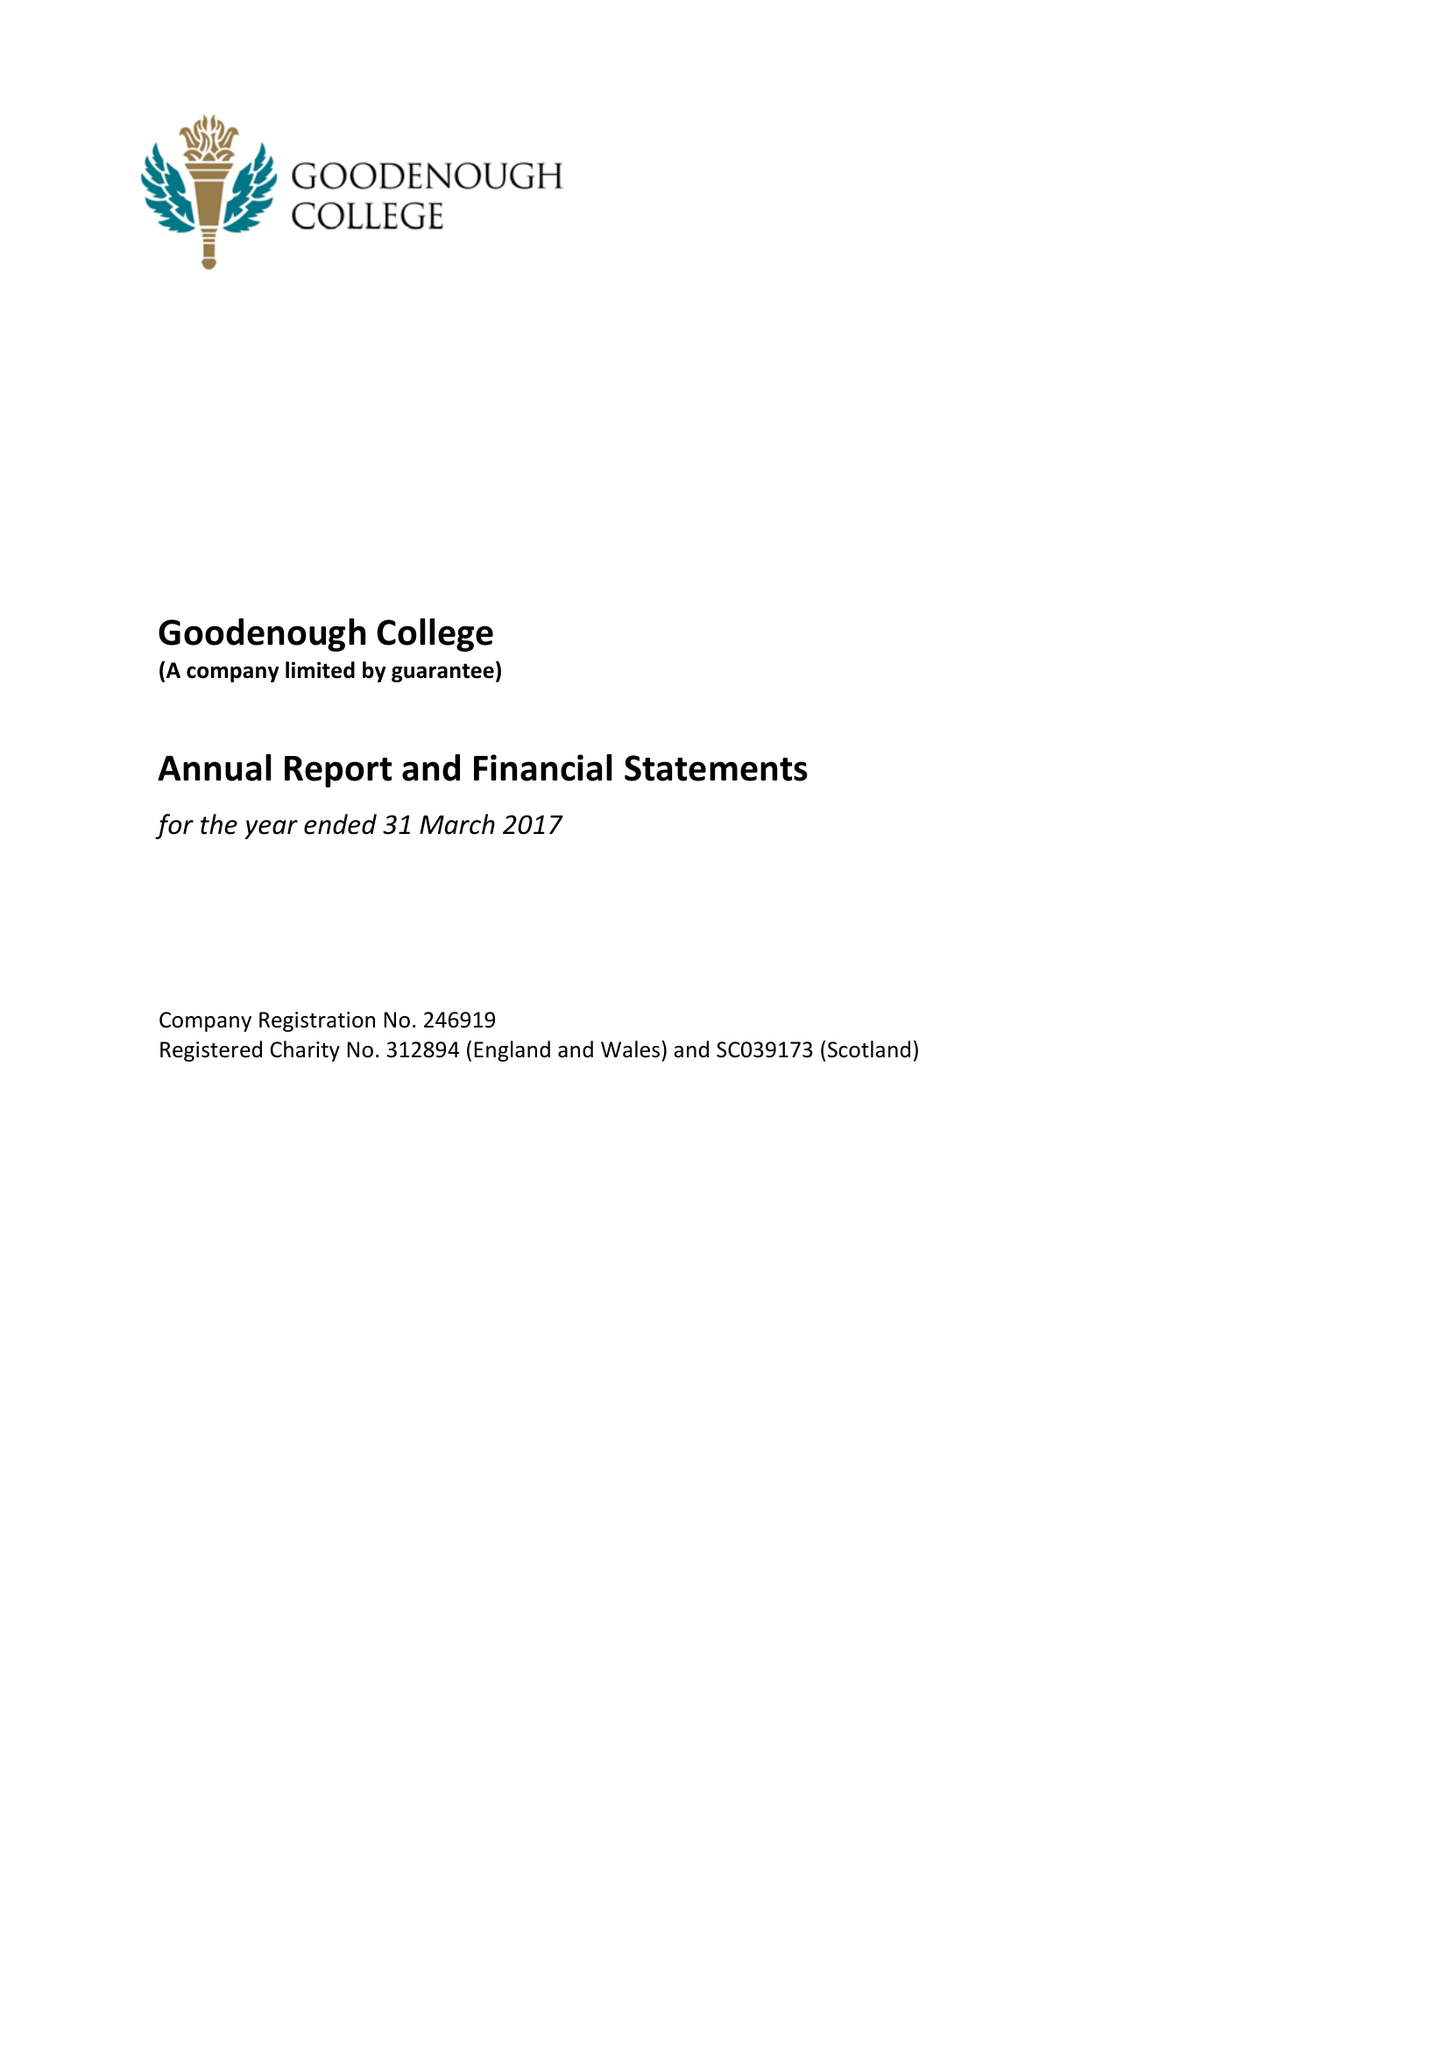What is the value for the income_annually_in_british_pounds?
Answer the question using a single word or phrase. 12149000.00 